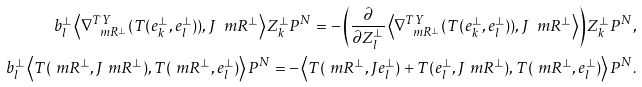<formula> <loc_0><loc_0><loc_500><loc_500>b ^ { \bot } _ { l } \left \langle \nabla ^ { T Y } _ { \ m R ^ { \bot } } ( T ( e ^ { \bot } _ { k } , e ^ { \bot } _ { l } ) ) , J \ m R ^ { \bot } \right \rangle Z _ { k } ^ { \bot } P ^ { N } = - \left ( \frac { \partial } { \partial Z ^ { \bot } _ { l } } \left \langle \nabla ^ { T Y } _ { \ m R ^ { \bot } } ( T ( e ^ { \bot } _ { k } , e ^ { \bot } _ { l } ) ) , J \ m R ^ { \bot } \right \rangle \right ) Z _ { k } ^ { \bot } P ^ { N } , \\ b ^ { \bot } _ { l } \left \langle T ( \ m R ^ { \bot } , J \ m R ^ { \bot } ) , T ( \ m R ^ { \bot } , e ^ { \bot } _ { l } ) \right \rangle P ^ { N } = - \left \langle T ( \ m R ^ { \bot } , J e ^ { \bot } _ { l } ) + T ( e ^ { \bot } _ { l } , J \ m R ^ { \bot } ) , T ( \ m R ^ { \bot } , e ^ { \bot } _ { l } ) \right \rangle P ^ { N } .</formula> 